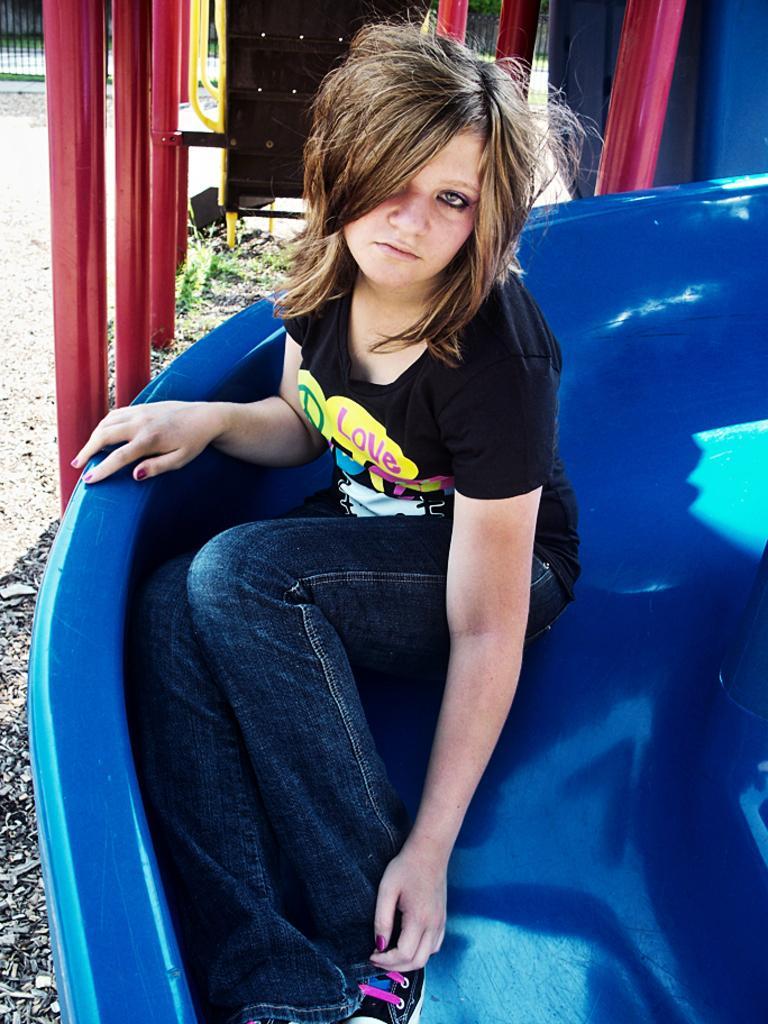Could you give a brief overview of what you see in this image? In this picture in the front there is a person sitting on a slider which is blue in colour. In the background there are poles which are red in colour and there is an object which is black in colour and there is grass on the ground. 